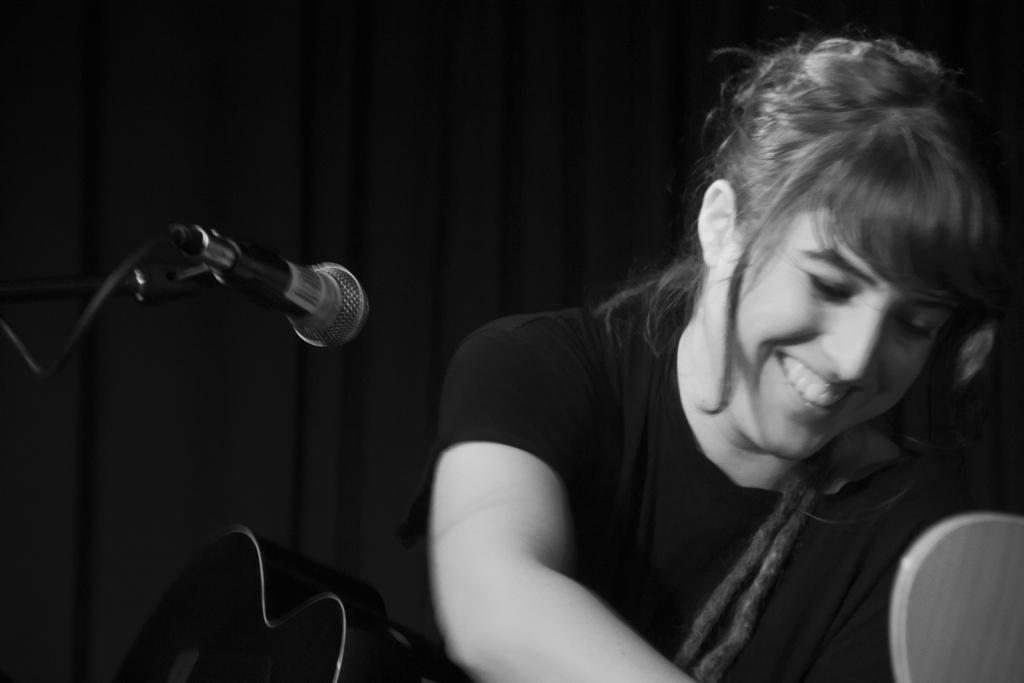Can you describe this image briefly? In this picture girl at the center is having smile on her face and holding a musical instrument. In the front there is a mic. 